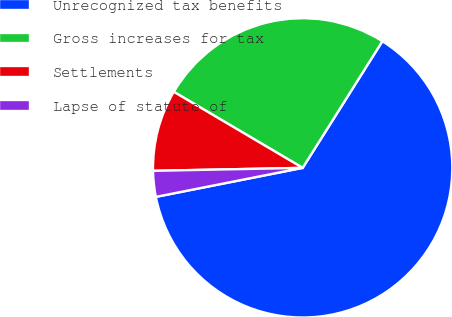Convert chart. <chart><loc_0><loc_0><loc_500><loc_500><pie_chart><fcel>Unrecognized tax benefits<fcel>Gross increases for tax<fcel>Settlements<fcel>Lapse of statute of<nl><fcel>62.95%<fcel>25.46%<fcel>8.8%<fcel>2.79%<nl></chart> 